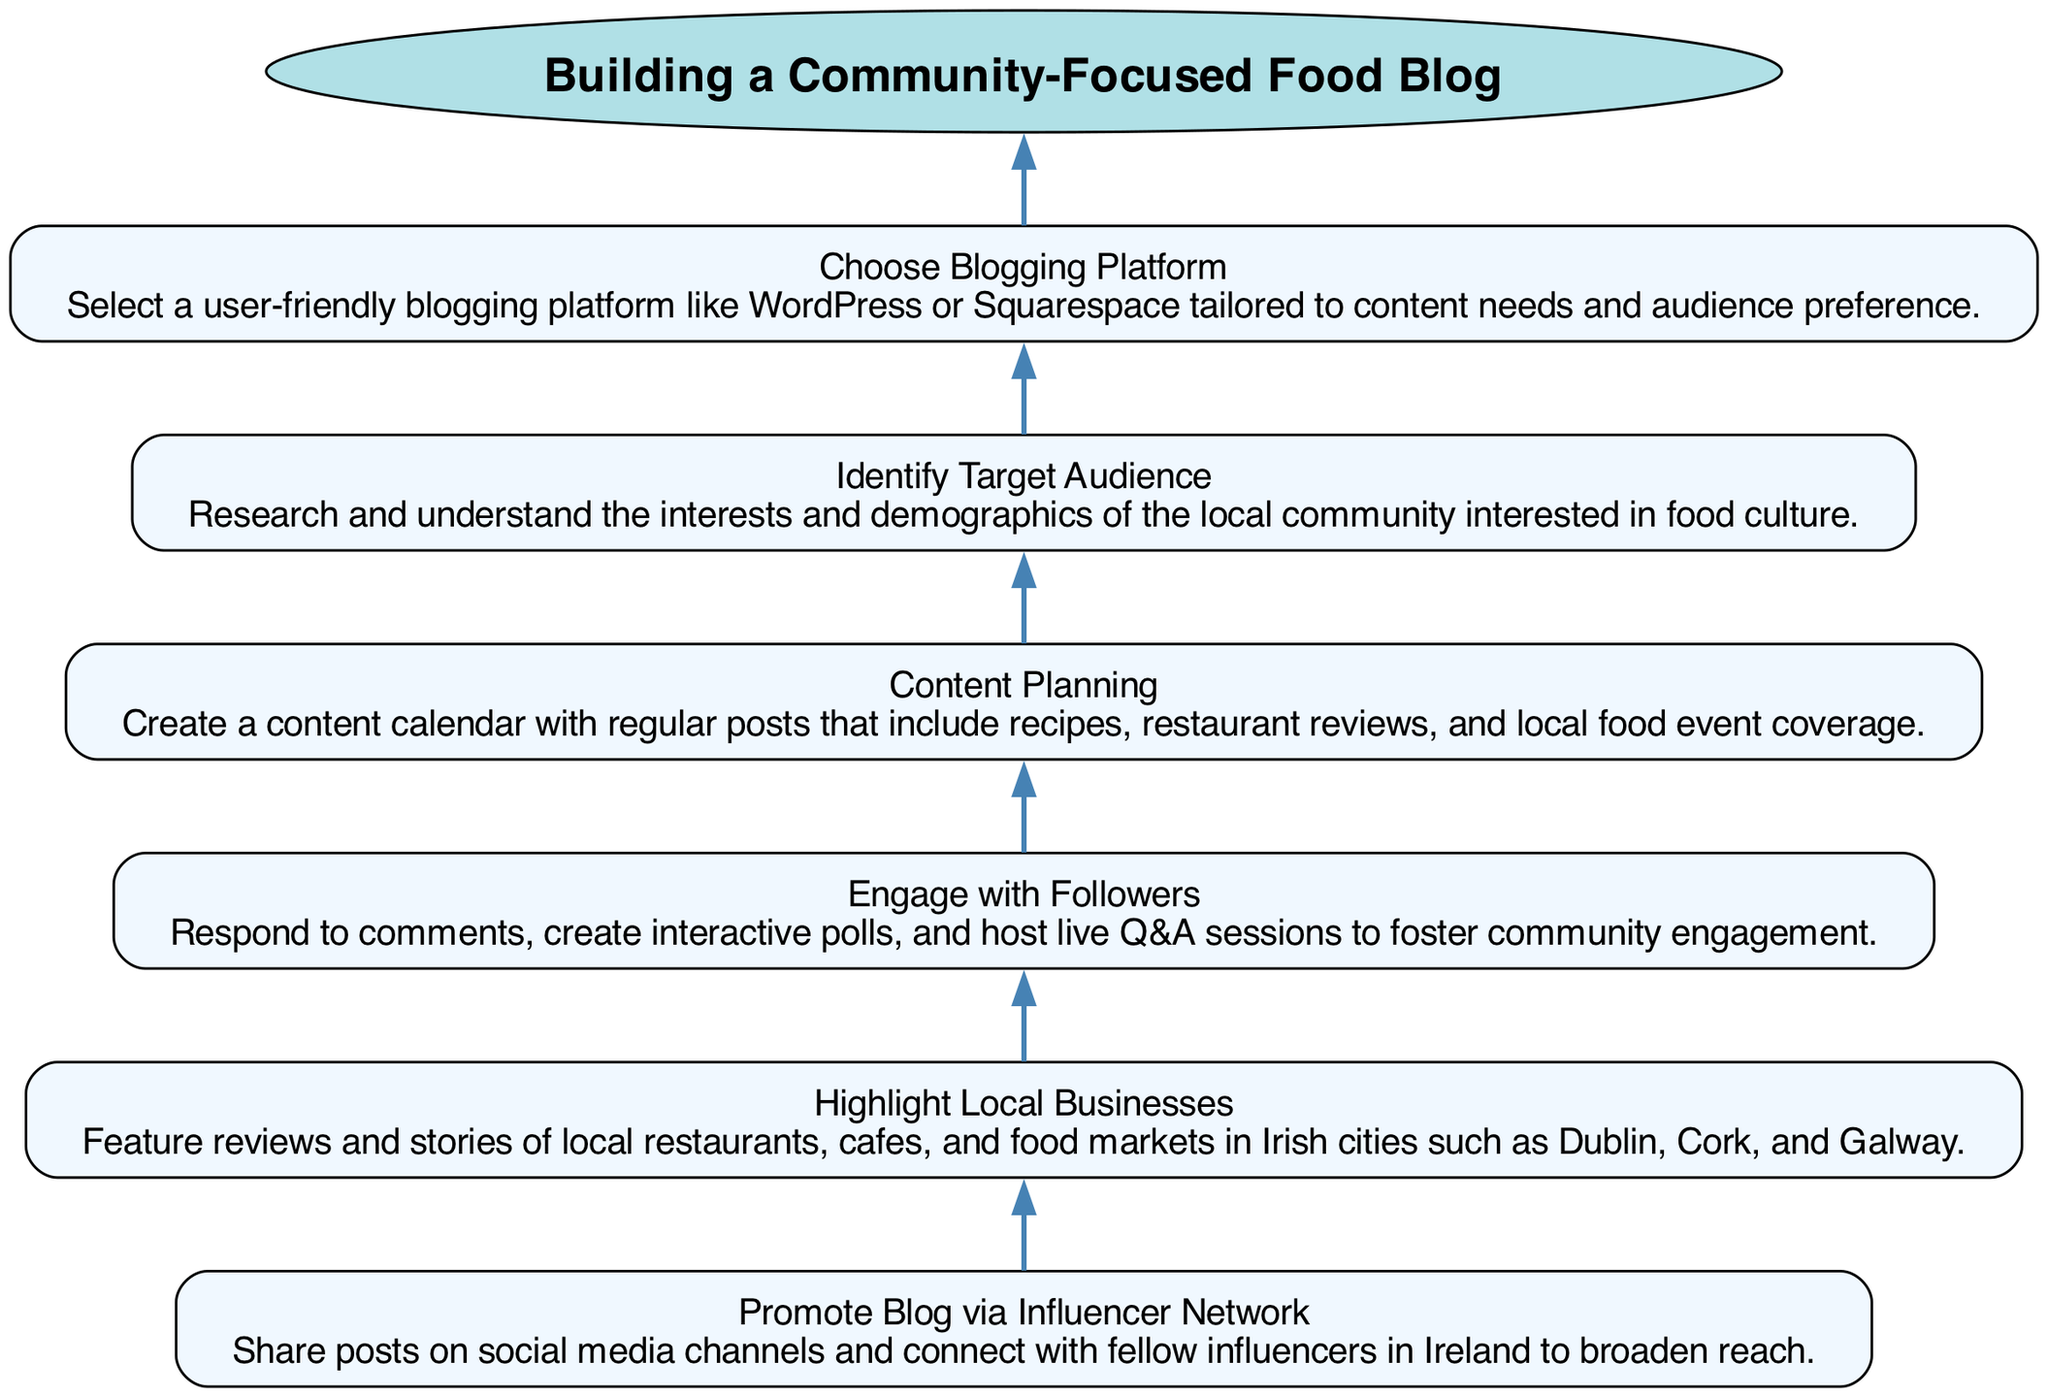What is the first step in building a community-focused food blog? The diagram shows that the first step is "Choose Blogging Platform," as it is the first element when following the upward flow.
Answer: Choose Blogging Platform How many nodes are included in the diagram? The diagram includes 6 nodes, each representing a distinct step in the process of building a community-focused food blog.
Answer: 6 Which step comes before "Promote Blog via Influencer Network"? By examining the diagram, "Highlight Local Businesses" directly precedes "Promote Blog via Influencer Network," creating a clear flow between these two elements.
Answer: Highlight Local Businesses What is the last node in the flow chart? The final element in the series when following the instruction flow upward is "Promote Blog via Influencer Network." This is determined by looking at the last step listed in the diagram.
Answer: Promote Blog via Influencer Network What happens after "Engage with Followers"? According to the diagram, after "Engage with Followers," the next step is "Promote Blog via Influencer Network," indicating a direct progression in the workflow.
Answer: Promote Blog via Influencer Network How does "Content Planning" relate to "Identify Target Audience"? The diagram shows that "Identify Target Audience" is a prerequisite to "Content Planning," establishing that understanding the audience is essential before planning the content.
Answer: Identifying the target audience is prior to content planning 